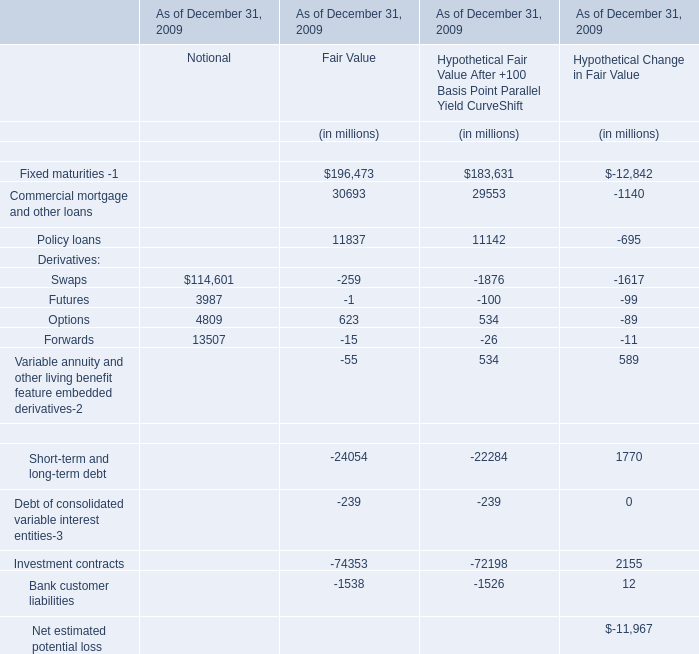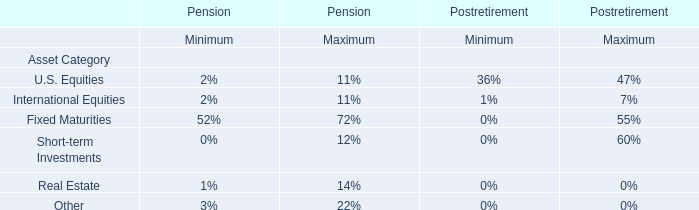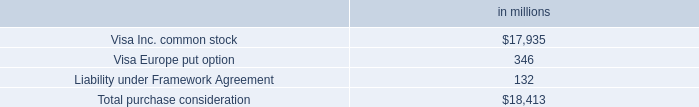In the section with largest amount of Forwards, what's the sum of elements? (in million) 
Computations: (((114601 + 3987) + 4809) + 13507)
Answer: 136904.0. 